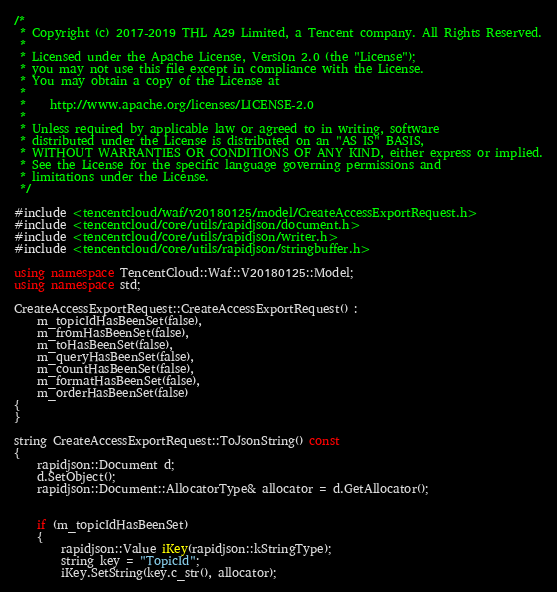Convert code to text. <code><loc_0><loc_0><loc_500><loc_500><_C++_>/*
 * Copyright (c) 2017-2019 THL A29 Limited, a Tencent company. All Rights Reserved.
 *
 * Licensed under the Apache License, Version 2.0 (the "License");
 * you may not use this file except in compliance with the License.
 * You may obtain a copy of the License at
 *
 *    http://www.apache.org/licenses/LICENSE-2.0
 *
 * Unless required by applicable law or agreed to in writing, software
 * distributed under the License is distributed on an "AS IS" BASIS,
 * WITHOUT WARRANTIES OR CONDITIONS OF ANY KIND, either express or implied.
 * See the License for the specific language governing permissions and
 * limitations under the License.
 */

#include <tencentcloud/waf/v20180125/model/CreateAccessExportRequest.h>
#include <tencentcloud/core/utils/rapidjson/document.h>
#include <tencentcloud/core/utils/rapidjson/writer.h>
#include <tencentcloud/core/utils/rapidjson/stringbuffer.h>

using namespace TencentCloud::Waf::V20180125::Model;
using namespace std;

CreateAccessExportRequest::CreateAccessExportRequest() :
    m_topicIdHasBeenSet(false),
    m_fromHasBeenSet(false),
    m_toHasBeenSet(false),
    m_queryHasBeenSet(false),
    m_countHasBeenSet(false),
    m_formatHasBeenSet(false),
    m_orderHasBeenSet(false)
{
}

string CreateAccessExportRequest::ToJsonString() const
{
    rapidjson::Document d;
    d.SetObject();
    rapidjson::Document::AllocatorType& allocator = d.GetAllocator();


    if (m_topicIdHasBeenSet)
    {
        rapidjson::Value iKey(rapidjson::kStringType);
        string key = "TopicId";
        iKey.SetString(key.c_str(), allocator);</code> 